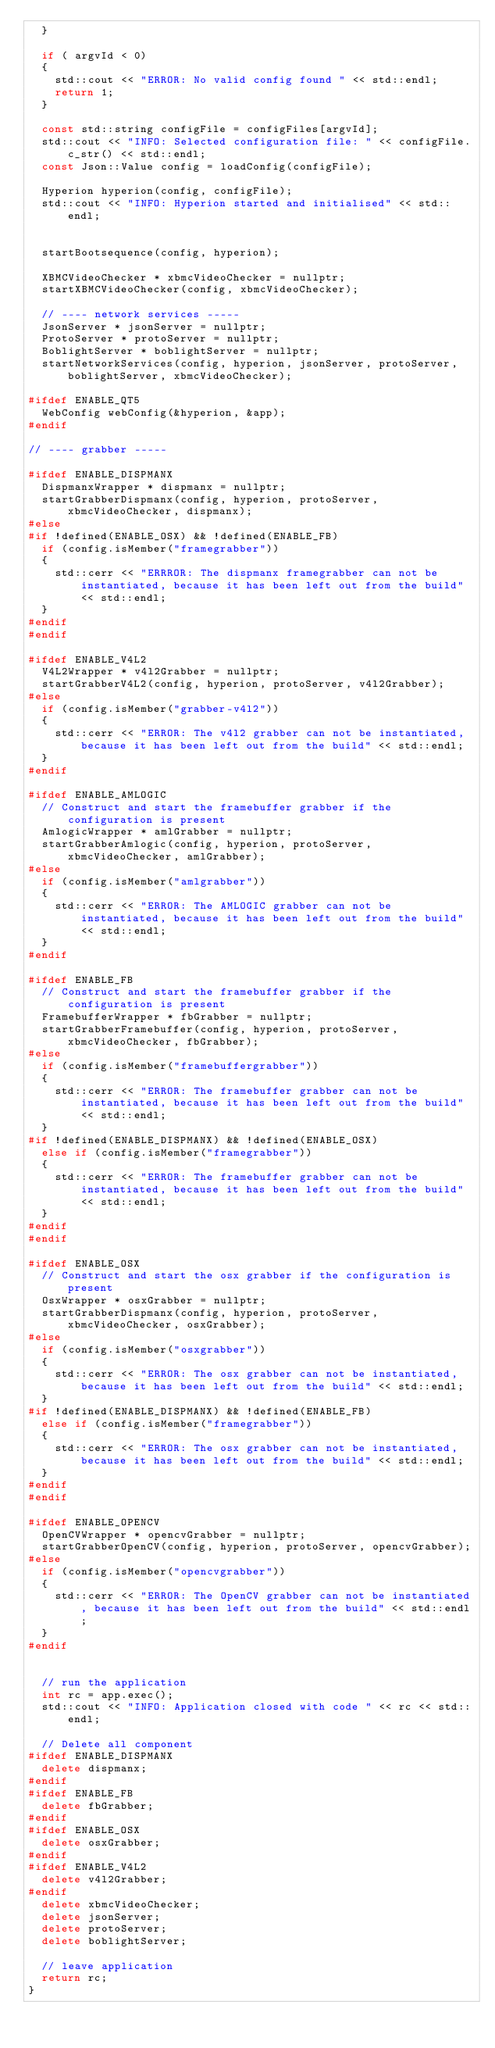<code> <loc_0><loc_0><loc_500><loc_500><_C++_>	}
	
	if ( argvId < 0)
	{
		std::cout << "ERROR: No valid config found " << std::endl;
		return 1;
	}
	
	const std::string configFile = configFiles[argvId];
	std::cout << "INFO: Selected configuration file: " << configFile.c_str() << std::endl;
	const Json::Value config = loadConfig(configFile);

	Hyperion hyperion(config, configFile);
	std::cout << "INFO: Hyperion started and initialised" << std::endl;


	startBootsequence(config, hyperion);

	XBMCVideoChecker * xbmcVideoChecker = nullptr;
	startXBMCVideoChecker(config, xbmcVideoChecker);

	// ---- network services -----
	JsonServer * jsonServer = nullptr;
	ProtoServer * protoServer = nullptr;
	BoblightServer * boblightServer = nullptr;
	startNetworkServices(config, hyperion, jsonServer, protoServer, boblightServer, xbmcVideoChecker);

#ifdef ENABLE_QT5
	WebConfig webConfig(&hyperion, &app);
#endif

// ---- grabber -----

#ifdef ENABLE_DISPMANX
	DispmanxWrapper * dispmanx = nullptr;
	startGrabberDispmanx(config, hyperion, protoServer, xbmcVideoChecker, dispmanx);
#else
#if !defined(ENABLE_OSX) && !defined(ENABLE_FB)
	if (config.isMember("framegrabber"))
	{
		std::cerr << "ERRROR: The dispmanx framegrabber can not be instantiated, because it has been left out from the build" << std::endl;
	}
#endif
#endif

#ifdef ENABLE_V4L2
	V4L2Wrapper * v4l2Grabber = nullptr;
	startGrabberV4L2(config, hyperion, protoServer, v4l2Grabber);
#else
	if (config.isMember("grabber-v4l2"))
	{
		std::cerr << "ERROR: The v4l2 grabber can not be instantiated, because it has been left out from the build" << std::endl;
	}
#endif

#ifdef ENABLE_AMLOGIC
	// Construct and start the framebuffer grabber if the configuration is present
	AmlogicWrapper * amlGrabber = nullptr;
	startGrabberAmlogic(config, hyperion, protoServer, xbmcVideoChecker, amlGrabber);
#else
	if (config.isMember("amlgrabber"))
	{
		std::cerr << "ERROR: The AMLOGIC grabber can not be instantiated, because it has been left out from the build" << std::endl;
	}
#endif

#ifdef ENABLE_FB
	// Construct and start the framebuffer grabber if the configuration is present
	FramebufferWrapper * fbGrabber = nullptr;
	startGrabberFramebuffer(config, hyperion, protoServer, xbmcVideoChecker, fbGrabber);
#else
	if (config.isMember("framebuffergrabber"))
	{
		std::cerr << "ERROR: The framebuffer grabber can not be instantiated, because it has been left out from the build" << std::endl;
	}
#if !defined(ENABLE_DISPMANX) && !defined(ENABLE_OSX)
	else if (config.isMember("framegrabber"))
	{
		std::cerr << "ERROR: The framebuffer grabber can not be instantiated, because it has been left out from the build" << std::endl;
	}
#endif
#endif

#ifdef ENABLE_OSX
	// Construct and start the osx grabber if the configuration is present
	OsxWrapper * osxGrabber = nullptr;
	startGrabberDispmanx(config, hyperion, protoServer, xbmcVideoChecker, osxGrabber);
#else
	if (config.isMember("osxgrabber"))
	{
		std::cerr << "ERROR: The osx grabber can not be instantiated, because it has been left out from the build" << std::endl;
	}
#if !defined(ENABLE_DISPMANX) && !defined(ENABLE_FB)
	else if (config.isMember("framegrabber"))
	{
		std::cerr << "ERROR: The osx grabber can not be instantiated, because it has been left out from the build" << std::endl;
	}
#endif
#endif

#ifdef ENABLE_OPENCV
	OpenCVWrapper * opencvGrabber = nullptr;
	startGrabberOpenCV(config, hyperion, protoServer, opencvGrabber);
#else
	if (config.isMember("opencvgrabber"))
	{
		std::cerr << "ERROR: The OpenCV grabber can not be instantiated, because it has been left out from the build" << std::endl;
	}
#endif


	// run the application
	int rc = app.exec();
	std::cout << "INFO: Application closed with code " << rc << std::endl;

	// Delete all component
#ifdef ENABLE_DISPMANX
	delete dispmanx;
#endif
#ifdef ENABLE_FB
	delete fbGrabber;
#endif
#ifdef ENABLE_OSX
	delete osxGrabber;
#endif
#ifdef ENABLE_V4L2
	delete v4l2Grabber;
#endif
	delete xbmcVideoChecker;
	delete jsonServer;
	delete protoServer;
	delete boblightServer;

	// leave application
	return rc;
}
</code> 